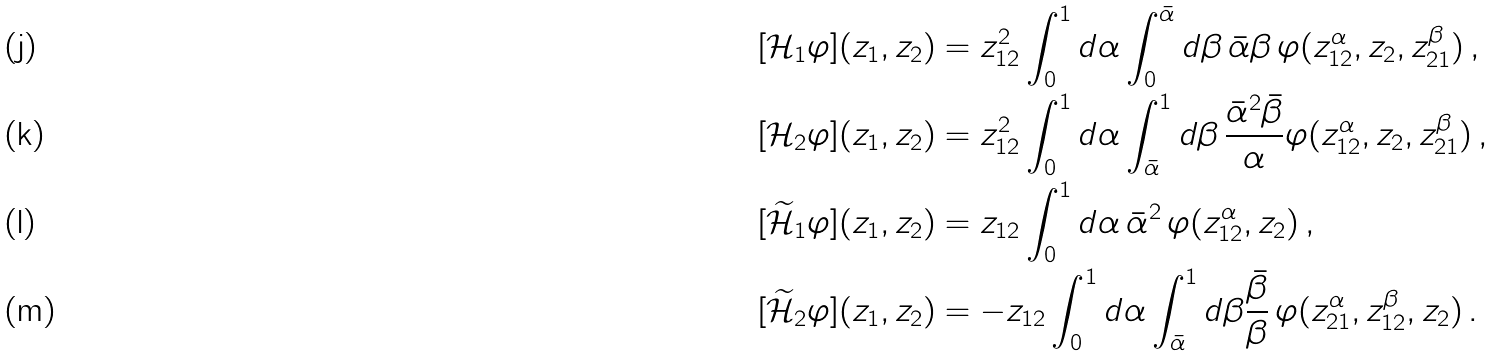<formula> <loc_0><loc_0><loc_500><loc_500>[ \mathcal { H } _ { 1 } \varphi ] ( z _ { 1 } , z _ { 2 } ) & = z _ { 1 2 } ^ { 2 } \int _ { 0 } ^ { 1 } d \alpha \int _ { 0 } ^ { \bar { \alpha } } d \beta \, \bar { \alpha } \beta \, \varphi ( z _ { 1 2 } ^ { \alpha } , z _ { 2 } , z _ { 2 1 } ^ { \beta } ) \, , \\ [ \mathcal { H } _ { 2 } \varphi ] ( z _ { 1 } , z _ { 2 } ) & = z _ { 1 2 } ^ { 2 } \int _ { 0 } ^ { 1 } d \alpha \int _ { \bar { \alpha } } ^ { 1 } d \beta \, \frac { \bar { \alpha } ^ { 2 } \bar { \beta } } { \alpha } \varphi ( z _ { 1 2 } ^ { \alpha } , z _ { 2 } , z _ { 2 1 } ^ { \beta } ) \, , \\ [ \widetilde { \mathcal { H } } _ { 1 } \varphi ] ( z _ { 1 } , z _ { 2 } ) & = z _ { 1 2 } \int _ { 0 } ^ { 1 } d \alpha \, \bar { \alpha } ^ { 2 } \, \varphi ( z _ { 1 2 } ^ { \alpha } , z _ { 2 } ) \, , \\ [ \widetilde { \mathcal { H } } _ { 2 } \varphi ] ( z _ { 1 } , z _ { 2 } ) & = - z _ { 1 2 } \int _ { 0 } ^ { 1 } d \alpha \int _ { \bar { \alpha } } ^ { 1 } d \beta \frac { \bar { \beta } } { \beta } \, \varphi ( z _ { 2 1 } ^ { \alpha } , z _ { 1 2 } ^ { \beta } , z _ { 2 } ) \, .</formula> 